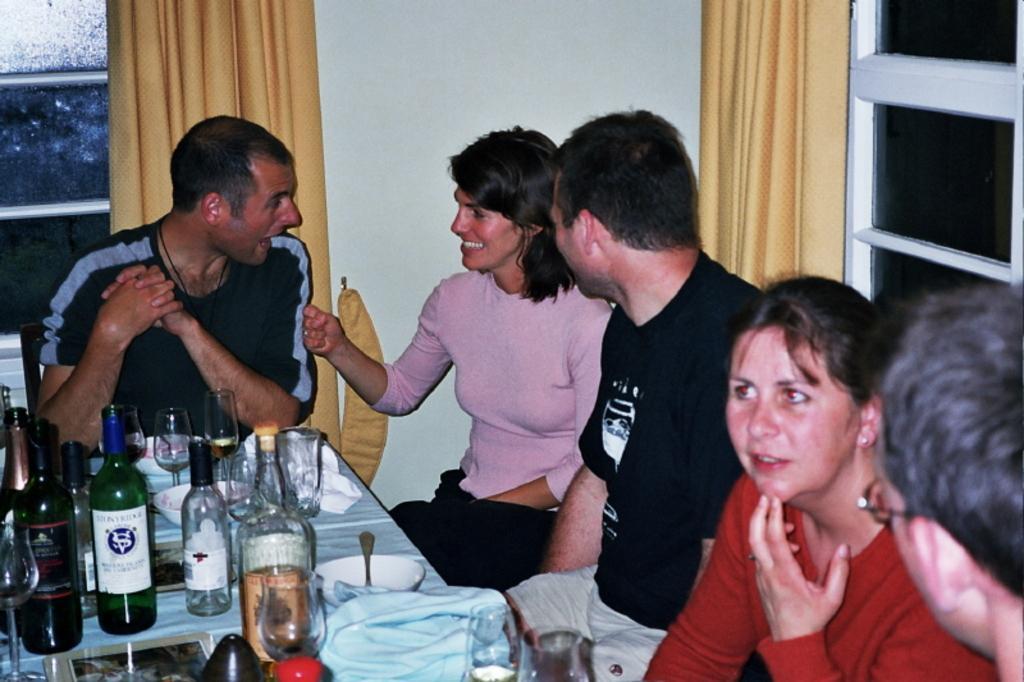Please provide a concise description of this image. There is a group of a people. They are sitting in a chair. There is a table. There is a wine bottle,glass,bowl and spoon on a table. We can see in the background there is a curtains and cupboard. 